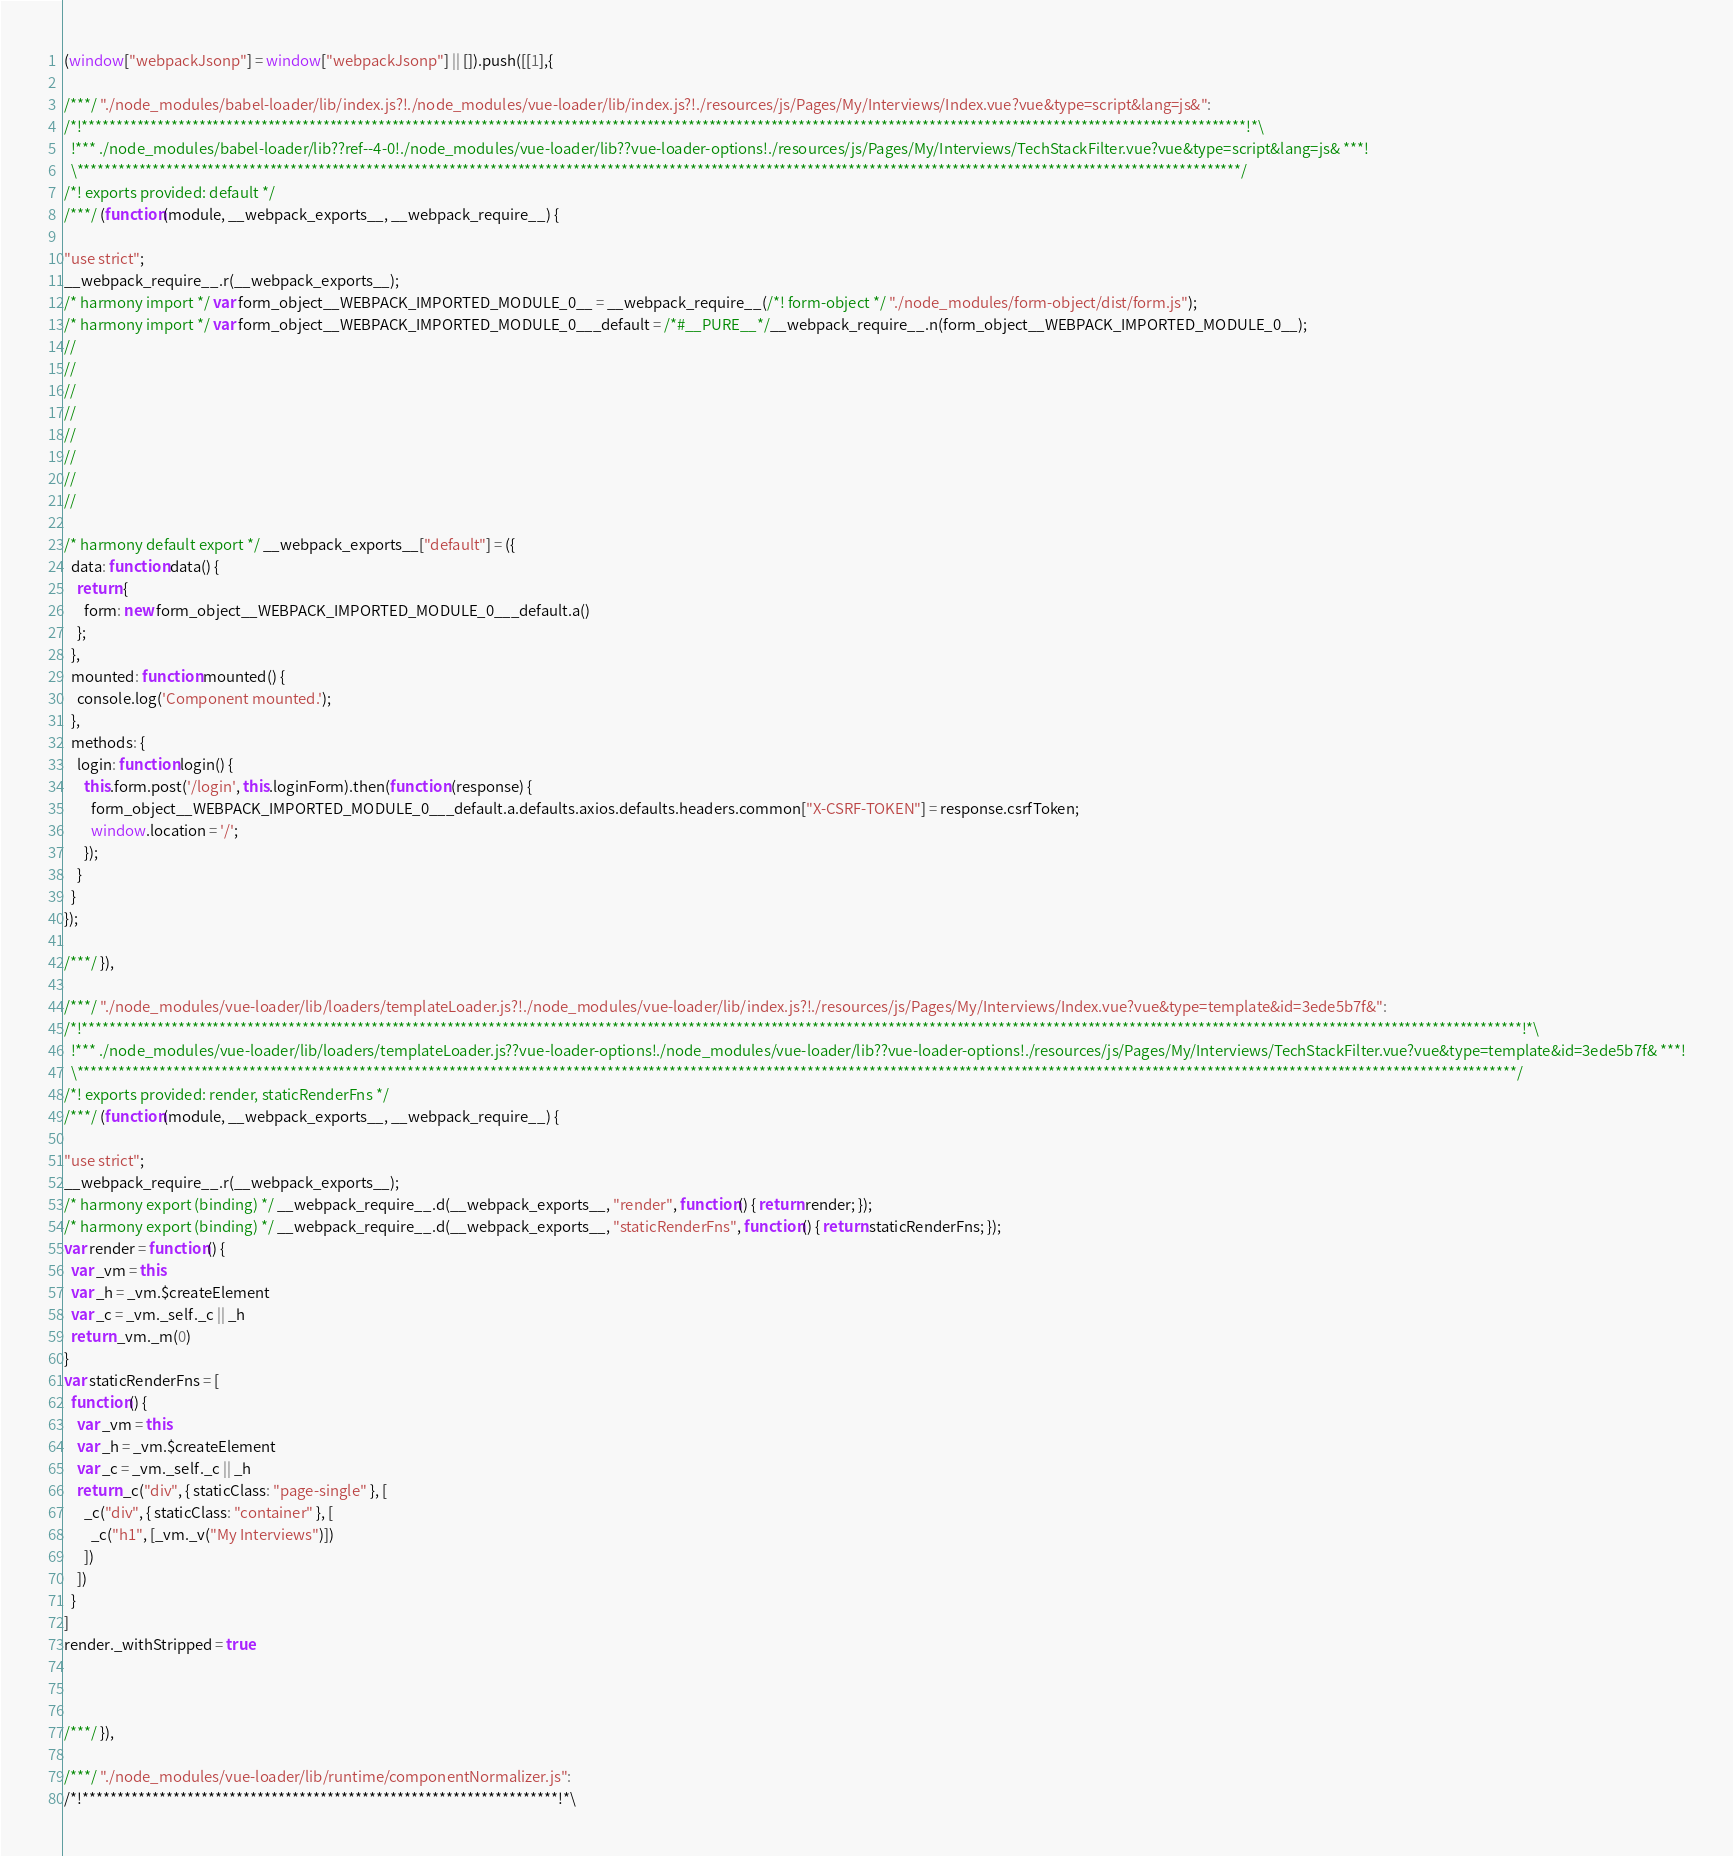Convert code to text. <code><loc_0><loc_0><loc_500><loc_500><_JavaScript_>(window["webpackJsonp"] = window["webpackJsonp"] || []).push([[1],{

/***/ "./node_modules/babel-loader/lib/index.js?!./node_modules/vue-loader/lib/index.js?!./resources/js/Pages/My/Interviews/Index.vue?vue&type=script&lang=js&":
/*!*************************************************************************************************************************************************************************!*\
  !*** ./node_modules/babel-loader/lib??ref--4-0!./node_modules/vue-loader/lib??vue-loader-options!./resources/js/Pages/My/Interviews/TechStackFilter.vue?vue&type=script&lang=js& ***!
  \*************************************************************************************************************************************************************************/
/*! exports provided: default */
/***/ (function(module, __webpack_exports__, __webpack_require__) {

"use strict";
__webpack_require__.r(__webpack_exports__);
/* harmony import */ var form_object__WEBPACK_IMPORTED_MODULE_0__ = __webpack_require__(/*! form-object */ "./node_modules/form-object/dist/form.js");
/* harmony import */ var form_object__WEBPACK_IMPORTED_MODULE_0___default = /*#__PURE__*/__webpack_require__.n(form_object__WEBPACK_IMPORTED_MODULE_0__);
//
//
//
//
//
//
//
//

/* harmony default export */ __webpack_exports__["default"] = ({
  data: function data() {
    return {
      form: new form_object__WEBPACK_IMPORTED_MODULE_0___default.a()
    };
  },
  mounted: function mounted() {
    console.log('Component mounted.');
  },
  methods: {
    login: function login() {
      this.form.post('/login', this.loginForm).then(function (response) {
        form_object__WEBPACK_IMPORTED_MODULE_0___default.a.defaults.axios.defaults.headers.common["X-CSRF-TOKEN"] = response.csrfToken;
        window.location = '/';
      });
    }
  }
});

/***/ }),

/***/ "./node_modules/vue-loader/lib/loaders/templateLoader.js?!./node_modules/vue-loader/lib/index.js?!./resources/js/Pages/My/Interviews/Index.vue?vue&type=template&id=3ede5b7f&":
/*!*****************************************************************************************************************************************************************************************************************!*\
  !*** ./node_modules/vue-loader/lib/loaders/templateLoader.js??vue-loader-options!./node_modules/vue-loader/lib??vue-loader-options!./resources/js/Pages/My/Interviews/TechStackFilter.vue?vue&type=template&id=3ede5b7f& ***!
  \*****************************************************************************************************************************************************************************************************************/
/*! exports provided: render, staticRenderFns */
/***/ (function(module, __webpack_exports__, __webpack_require__) {

"use strict";
__webpack_require__.r(__webpack_exports__);
/* harmony export (binding) */ __webpack_require__.d(__webpack_exports__, "render", function() { return render; });
/* harmony export (binding) */ __webpack_require__.d(__webpack_exports__, "staticRenderFns", function() { return staticRenderFns; });
var render = function() {
  var _vm = this
  var _h = _vm.$createElement
  var _c = _vm._self._c || _h
  return _vm._m(0)
}
var staticRenderFns = [
  function() {
    var _vm = this
    var _h = _vm.$createElement
    var _c = _vm._self._c || _h
    return _c("div", { staticClass: "page-single" }, [
      _c("div", { staticClass: "container" }, [
        _c("h1", [_vm._v("My Interviews")])
      ])
    ])
  }
]
render._withStripped = true



/***/ }),

/***/ "./node_modules/vue-loader/lib/runtime/componentNormalizer.js":
/*!********************************************************************!*\</code> 